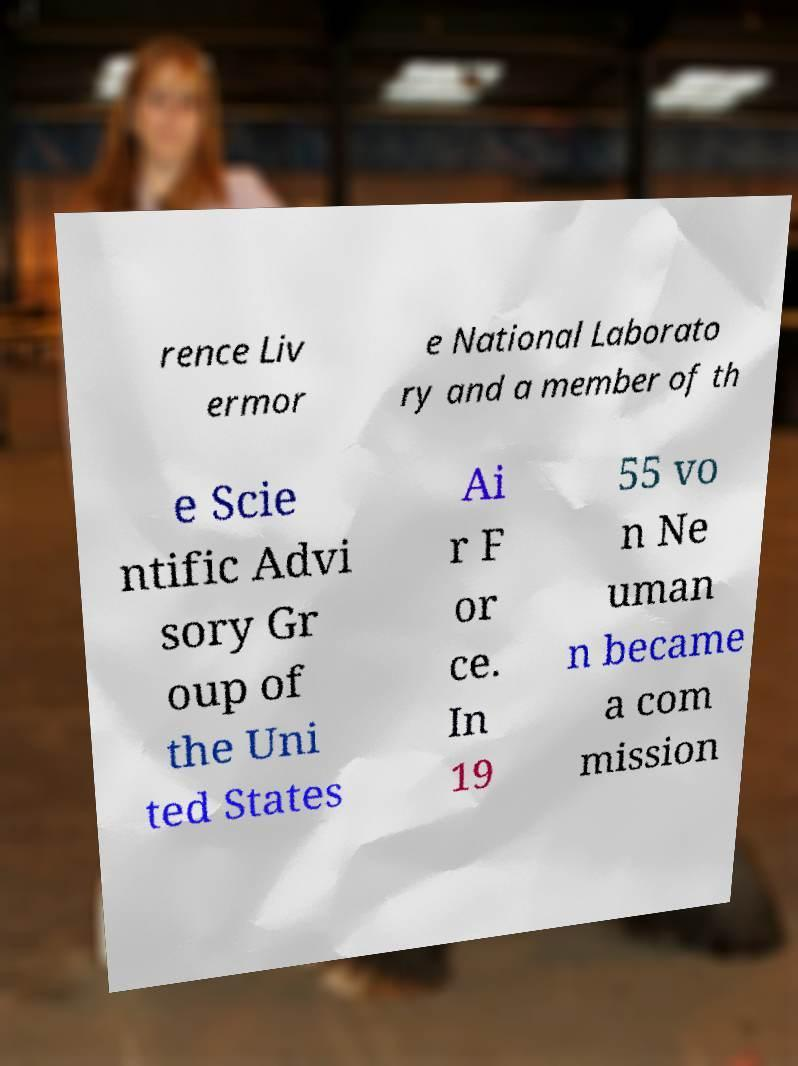For documentation purposes, I need the text within this image transcribed. Could you provide that? rence Liv ermor e National Laborato ry and a member of th e Scie ntific Advi sory Gr oup of the Uni ted States Ai r F or ce. In 19 55 vo n Ne uman n became a com mission 